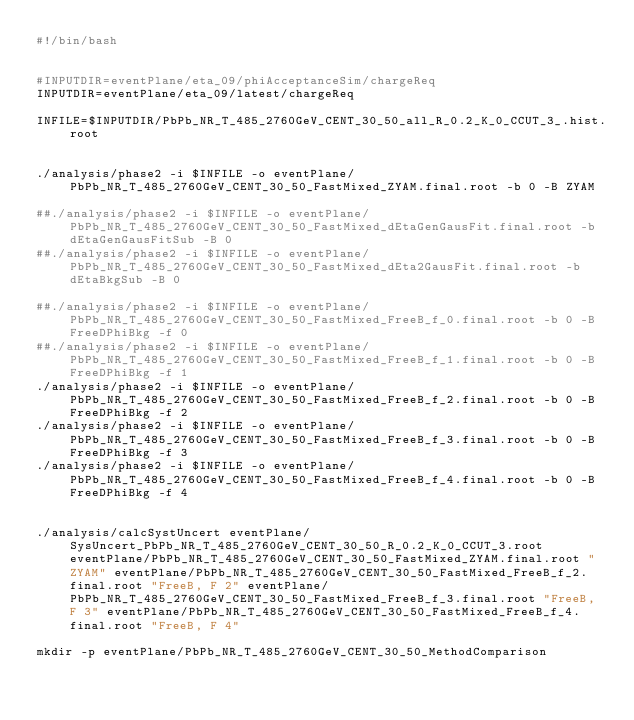<code> <loc_0><loc_0><loc_500><loc_500><_Bash_>#!/bin/bash


#INPUTDIR=eventPlane/eta_09/phiAcceptanceSim/chargeReq
INPUTDIR=eventPlane/eta_09/latest/chargeReq

INFILE=$INPUTDIR/PbPb_NR_T_485_2760GeV_CENT_30_50_all_R_0.2_K_0_CCUT_3_.hist.root


./analysis/phase2 -i $INFILE -o eventPlane/PbPb_NR_T_485_2760GeV_CENT_30_50_FastMixed_ZYAM.final.root -b 0 -B ZYAM

##./analysis/phase2 -i $INFILE -o eventPlane/PbPb_NR_T_485_2760GeV_CENT_30_50_FastMixed_dEtaGenGausFit.final.root -b dEtaGenGausFitSub -B 0
##./analysis/phase2 -i $INFILE -o eventPlane/PbPb_NR_T_485_2760GeV_CENT_30_50_FastMixed_dEta2GausFit.final.root -b dEtaBkgSub -B 0

##./analysis/phase2 -i $INFILE -o eventPlane/PbPb_NR_T_485_2760GeV_CENT_30_50_FastMixed_FreeB_f_0.final.root -b 0 -B FreeDPhiBkg -f 0
##./analysis/phase2 -i $INFILE -o eventPlane/PbPb_NR_T_485_2760GeV_CENT_30_50_FastMixed_FreeB_f_1.final.root -b 0 -B FreeDPhiBkg -f 1
./analysis/phase2 -i $INFILE -o eventPlane/PbPb_NR_T_485_2760GeV_CENT_30_50_FastMixed_FreeB_f_2.final.root -b 0 -B FreeDPhiBkg -f 2
./analysis/phase2 -i $INFILE -o eventPlane/PbPb_NR_T_485_2760GeV_CENT_30_50_FastMixed_FreeB_f_3.final.root -b 0 -B FreeDPhiBkg -f 3
./analysis/phase2 -i $INFILE -o eventPlane/PbPb_NR_T_485_2760GeV_CENT_30_50_FastMixed_FreeB_f_4.final.root -b 0 -B FreeDPhiBkg -f 4


./analysis/calcSystUncert eventPlane/SysUncert_PbPb_NR_T_485_2760GeV_CENT_30_50_R_0.2_K_0_CCUT_3.root eventPlane/PbPb_NR_T_485_2760GeV_CENT_30_50_FastMixed_ZYAM.final.root "ZYAM" eventPlane/PbPb_NR_T_485_2760GeV_CENT_30_50_FastMixed_FreeB_f_2.final.root "FreeB, F 2" eventPlane/PbPb_NR_T_485_2760GeV_CENT_30_50_FastMixed_FreeB_f_3.final.root "FreeB, F 3" eventPlane/PbPb_NR_T_485_2760GeV_CENT_30_50_FastMixed_FreeB_f_4.final.root "FreeB, F 4"

mkdir -p eventPlane/PbPb_NR_T_485_2760GeV_CENT_30_50_MethodComparison 
</code> 